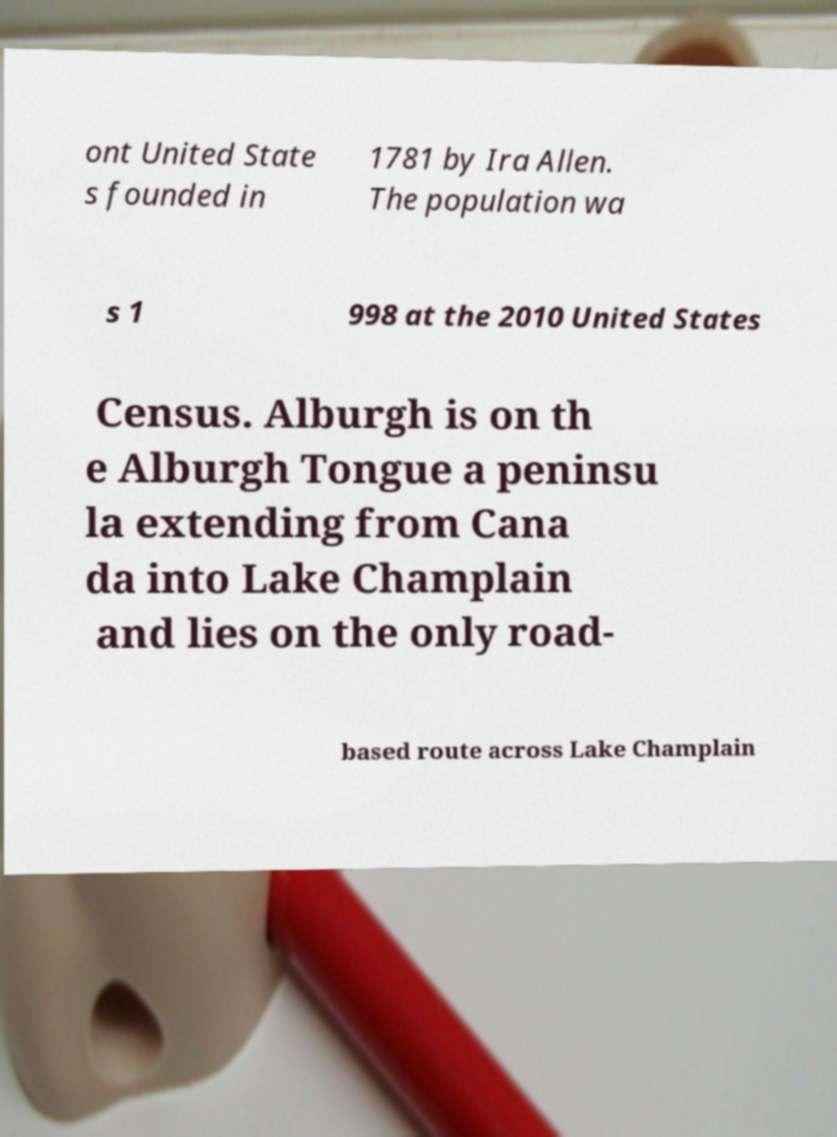For documentation purposes, I need the text within this image transcribed. Could you provide that? ont United State s founded in 1781 by Ira Allen. The population wa s 1 998 at the 2010 United States Census. Alburgh is on th e Alburgh Tongue a peninsu la extending from Cana da into Lake Champlain and lies on the only road- based route across Lake Champlain 